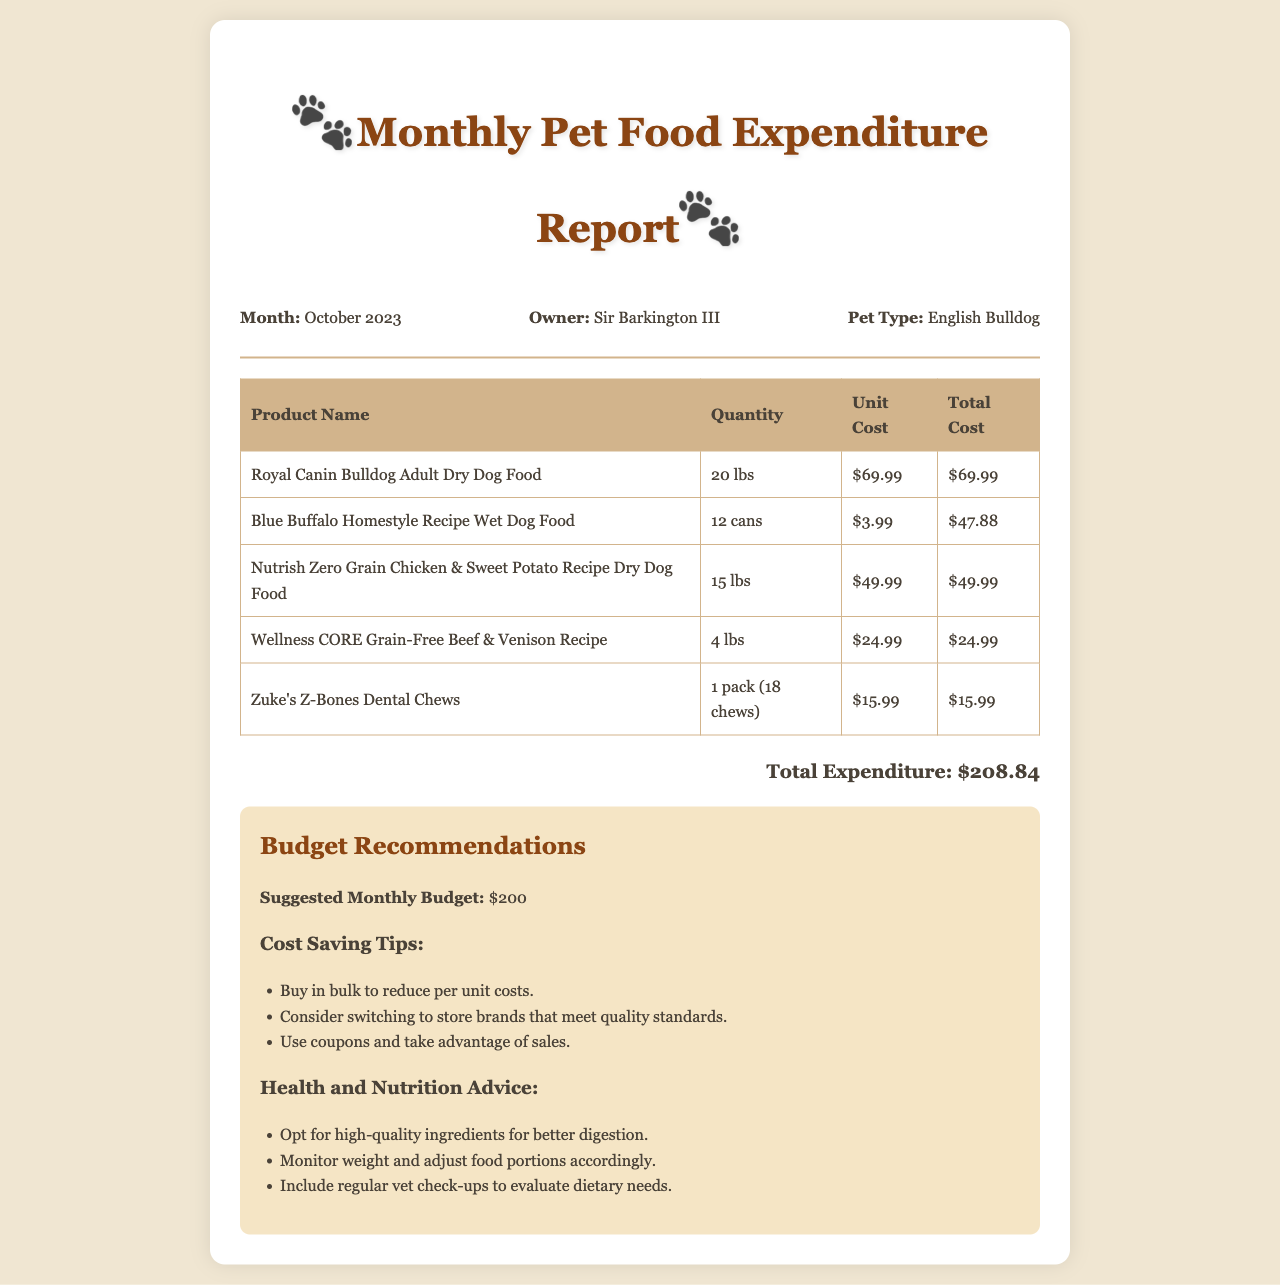What is the total expenditure reported? The total expenditure is located at the end of the table and is a sum of all the listed costs, which equals $208.84.
Answer: $208.84 What product has the highest unit cost? The product with the highest unit cost can be found by comparing the unit costs in the table, revealing it to be Royal Canin Bulldog Adult Dry Dog Food at $69.99.
Answer: Royal Canin Bulldog Adult Dry Dog Food How many cans of Blue Buffalo are purchased? The quantity of Blue Buffalo Homestyle Recipe Wet Dog Food is specified in the table as 12 cans.
Answer: 12 cans What is the suggested monthly budget? The suggested monthly budget is mentioned in the recommendations section and should be maintained at or below this amount, which is $200.
Answer: $200 What is a cost-saving tip provided in the recommendations? One of the cost-saving tips listed in the recommendations section suggests buying in bulk to reduce per-unit costs.
Answer: Buy in bulk What is the pet type listed in the document? The pet type can be found within the header information section, which states that the pet is an English Bulldog.
Answer: English Bulldog What is the weight of Nutrish Zero Grain Chicken & Sweet Potato Recipe? The weight for this product is noted in the table, showing it's purchased in a quantity of 15 lbs.
Answer: 15 lbs How many Zuke's Z-Bones are in one pack? The number of chews in one pack of Zuke's Z-Bones is indicated in the table as 18 chews.
Answer: 18 chews What is the total cost of Wellness CORE Grain-Free recipe? The total cost for the Wellness CORE Grain-Free recipe is shown in the table under total cost, equaling $24.99.
Answer: $24.99 